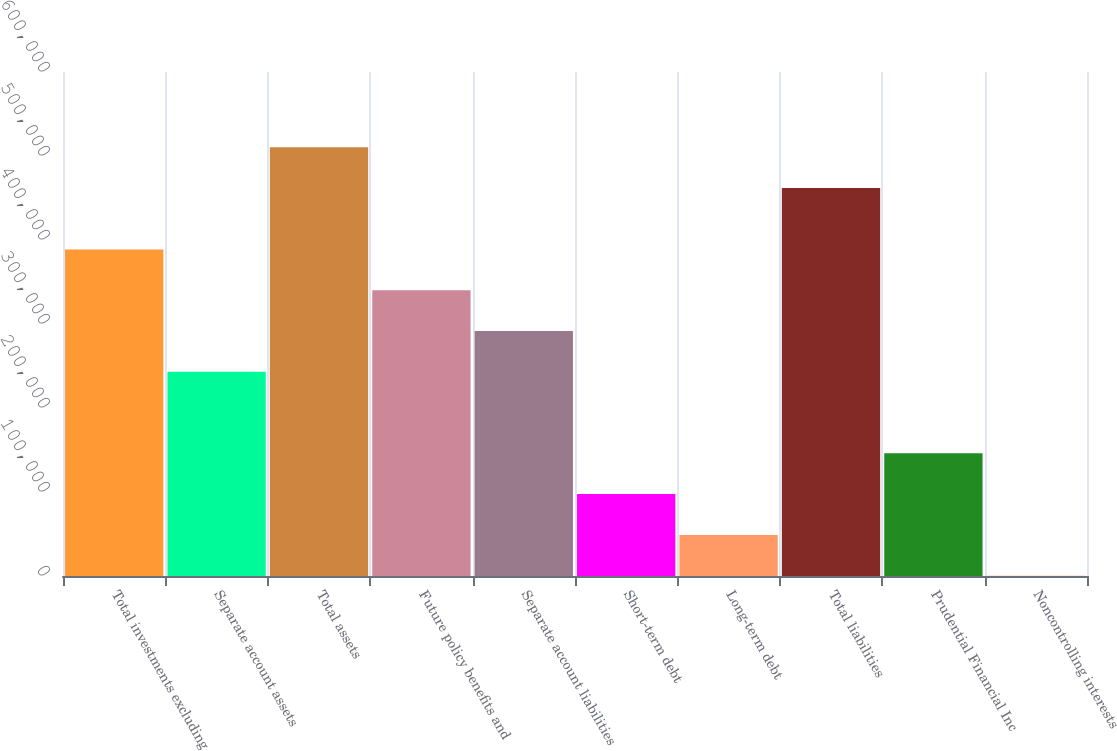<chart> <loc_0><loc_0><loc_500><loc_500><bar_chart><fcel>Total investments excluding<fcel>Separate account assets<fcel>Total assets<fcel>Future policy benefits and<fcel>Separate account liabilities<fcel>Short-term debt<fcel>Long-term debt<fcel>Total liabilities<fcel>Prudential Financial Inc<fcel>Noncontrolling interests<nl><fcel>388732<fcel>243111<fcel>510430<fcel>340192<fcel>291651<fcel>97489.8<fcel>48949.4<fcel>461890<fcel>146030<fcel>409<nl></chart> 